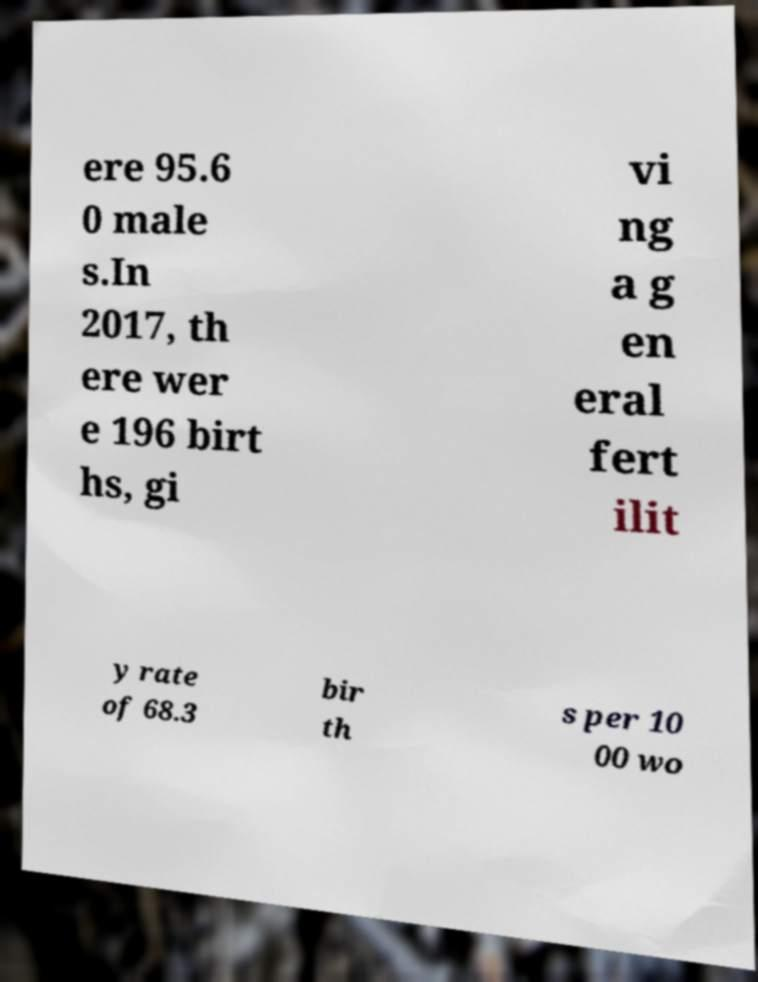Please read and relay the text visible in this image. What does it say? ere 95.6 0 male s.In 2017, th ere wer e 196 birt hs, gi vi ng a g en eral fert ilit y rate of 68.3 bir th s per 10 00 wo 